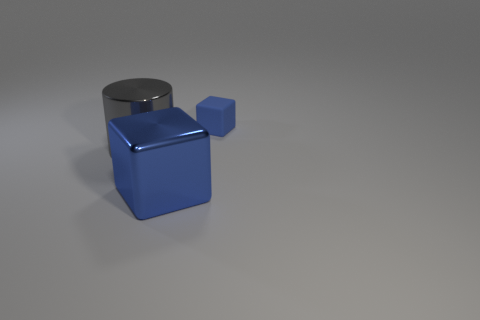Are there any other things that have the same material as the tiny object?
Keep it short and to the point. No. How many objects are behind the shiny cube and to the right of the big gray object?
Make the answer very short. 1. How many other things are the same shape as the matte object?
Ensure brevity in your answer.  1. Are there more blue objects that are to the right of the large blue object than blue spheres?
Offer a terse response. Yes. What is the color of the shiny thing that is to the left of the blue metallic cube?
Your answer should be very brief. Gray. The shiny thing that is the same color as the matte thing is what size?
Offer a very short reply. Large. What number of rubber objects are either large blocks or large blue cylinders?
Offer a very short reply. 0. Are there any cubes that are to the right of the big object on the left side of the big metal object that is in front of the big gray shiny object?
Offer a terse response. Yes. There is a big gray thing; what number of tiny blue blocks are behind it?
Keep it short and to the point. 1. There is a tiny thing that is the same color as the large shiny cube; what material is it?
Keep it short and to the point. Rubber. 